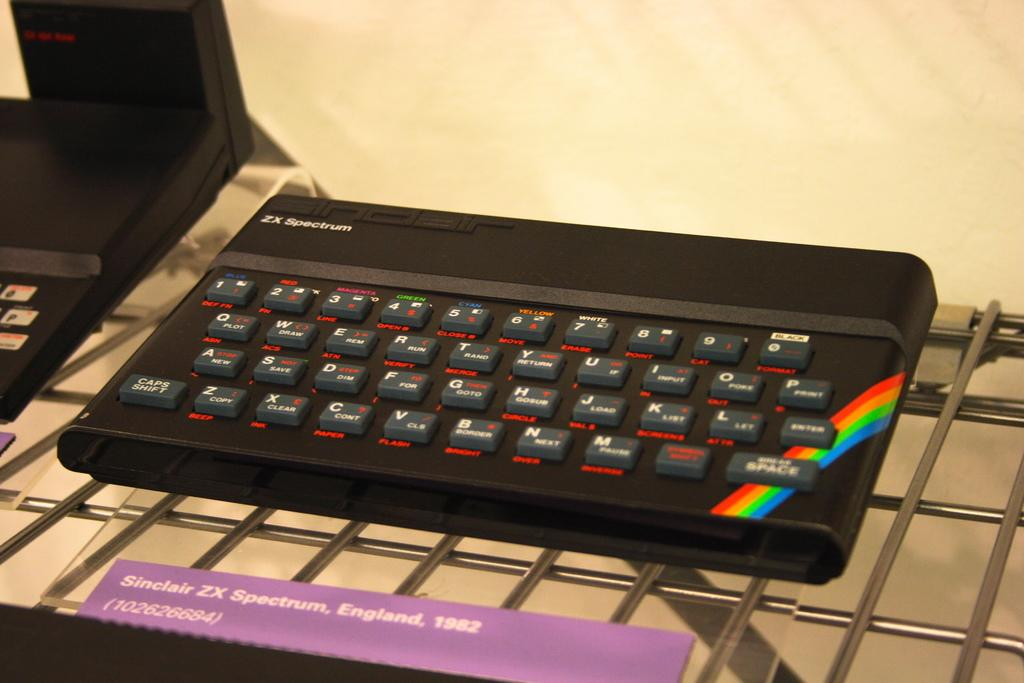Provide a one-sentence caption for the provided image. A keyboard that was created in England in 1982. 